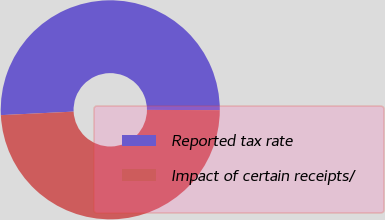Convert chart to OTSL. <chart><loc_0><loc_0><loc_500><loc_500><pie_chart><fcel>Reported tax rate<fcel>Impact of certain receipts/<nl><fcel>50.82%<fcel>49.18%<nl></chart> 